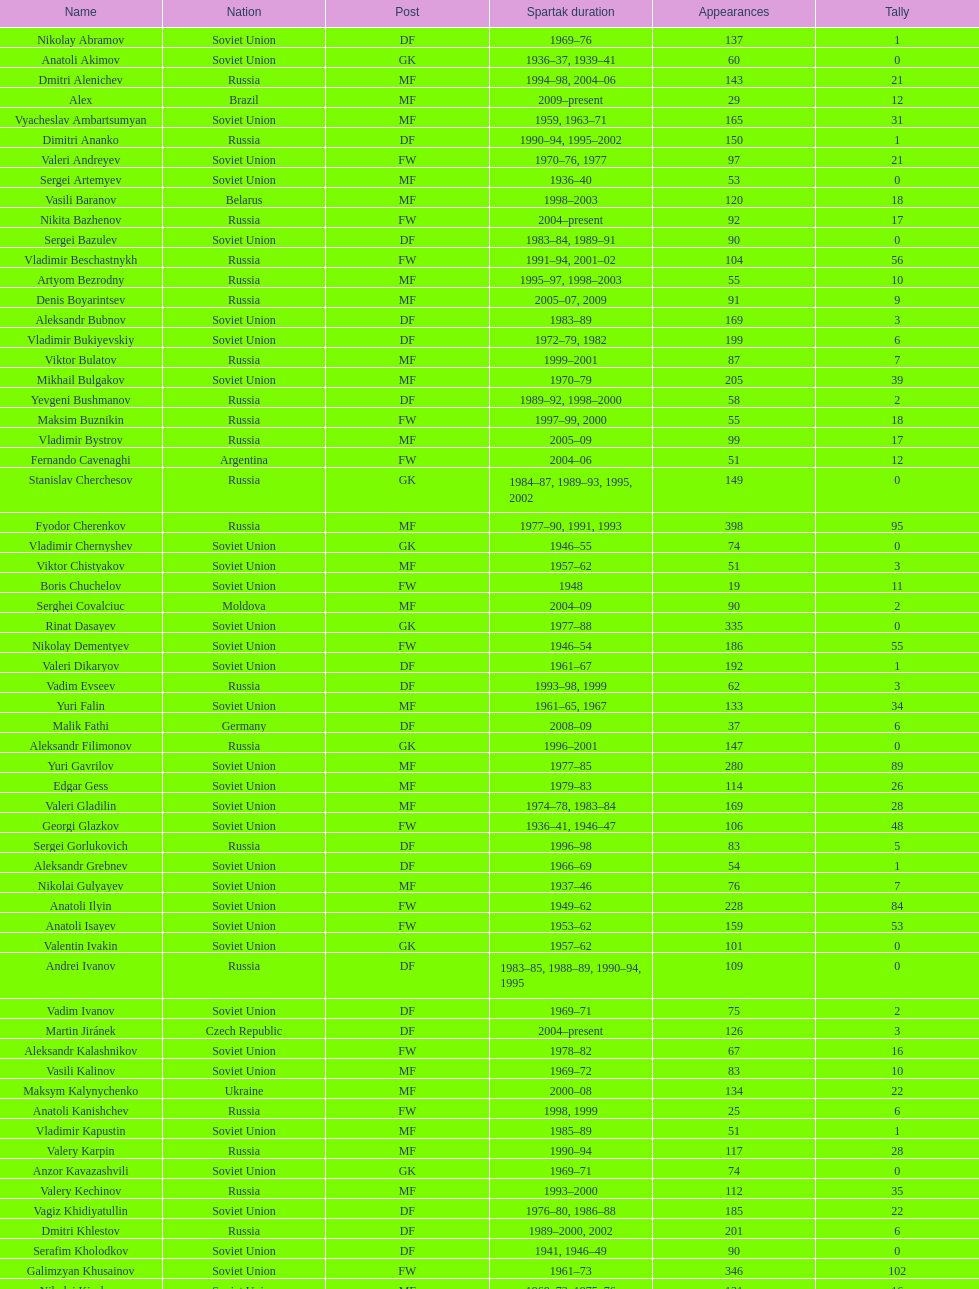Vladimir bukiyevskiy had how many appearances? 199. 